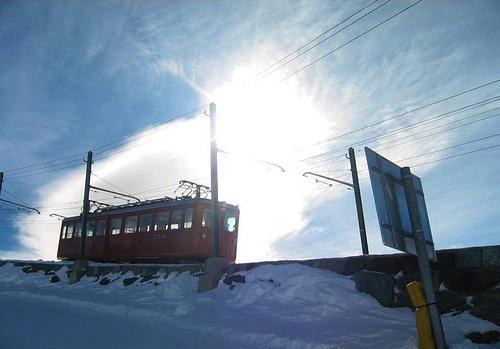How many people are sitting on the bench?
Give a very brief answer. 0. 